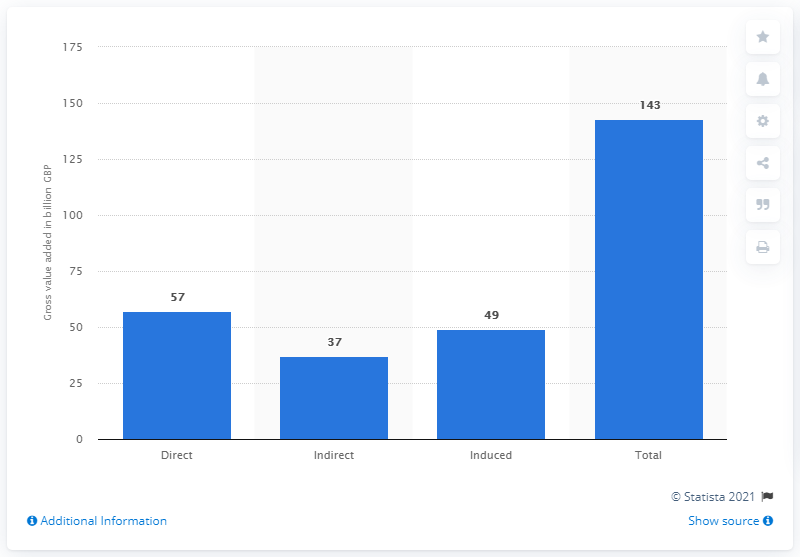Outline some significant characteristics in this image. The direct GVA (Gross Value Added) of the hospitality industry in the UK in 2014 was £57 billion. 